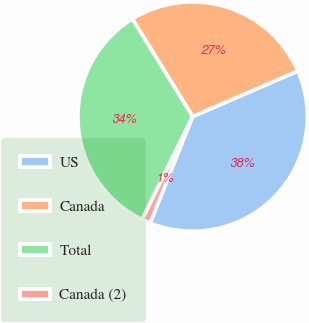Convert chart to OTSL. <chart><loc_0><loc_0><loc_500><loc_500><pie_chart><fcel>US<fcel>Canada<fcel>Total<fcel>Canada (2)<nl><fcel>37.55%<fcel>27.3%<fcel>33.94%<fcel>1.2%<nl></chart> 